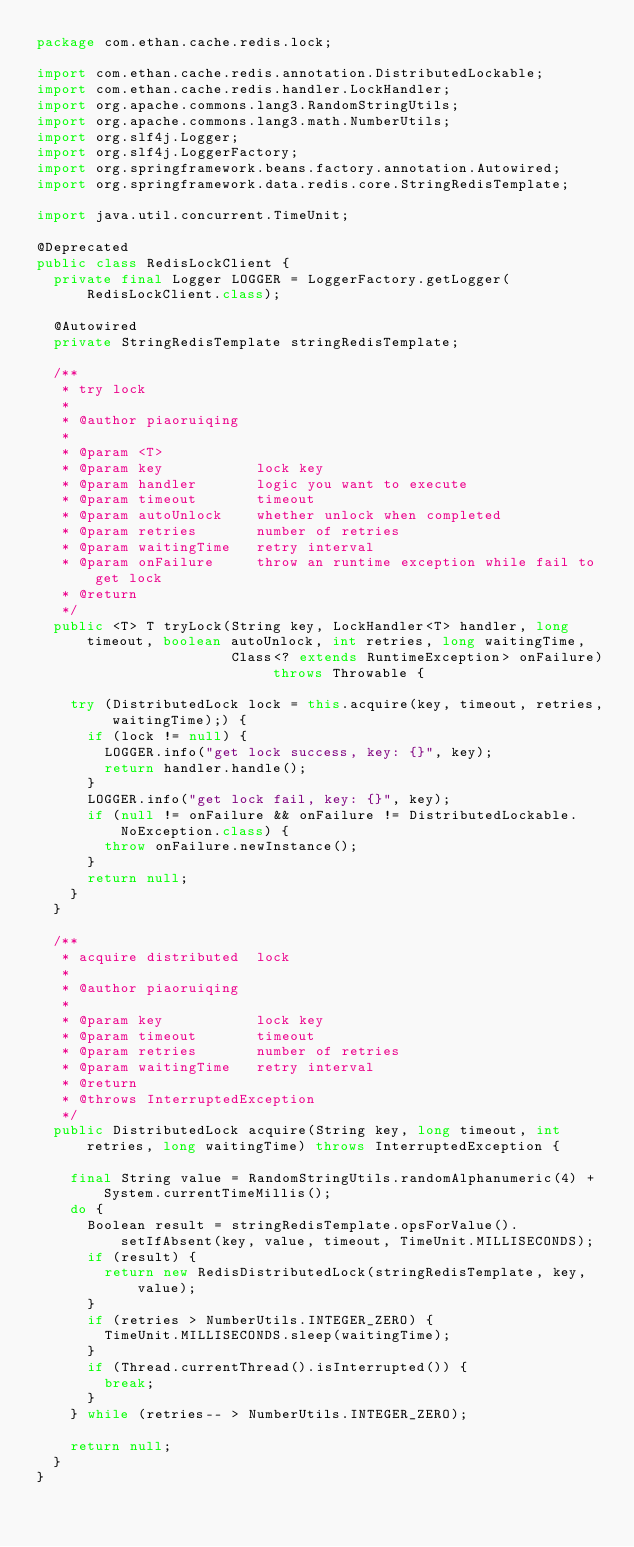Convert code to text. <code><loc_0><loc_0><loc_500><loc_500><_Java_>package com.ethan.cache.redis.lock;

import com.ethan.cache.redis.annotation.DistributedLockable;
import com.ethan.cache.redis.handler.LockHandler;
import org.apache.commons.lang3.RandomStringUtils;
import org.apache.commons.lang3.math.NumberUtils;
import org.slf4j.Logger;
import org.slf4j.LoggerFactory;
import org.springframework.beans.factory.annotation.Autowired;
import org.springframework.data.redis.core.StringRedisTemplate;

import java.util.concurrent.TimeUnit;

@Deprecated
public class RedisLockClient {
  private final Logger LOGGER = LoggerFactory.getLogger(RedisLockClient.class);

  @Autowired
  private StringRedisTemplate stringRedisTemplate;

  /**
   * try lock
   *
   * @author piaoruiqing
   *
   * @param <T>
   * @param key           lock key
   * @param handler       logic you want to execute
   * @param timeout       timeout
   * @param autoUnlock    whether unlock when completed
   * @param retries       number of retries
   * @param waitingTime   retry interval
   * @param onFailure     throw an runtime exception while fail to get lock
   * @return
   */
  public <T> T tryLock(String key, LockHandler<T> handler, long timeout, boolean autoUnlock, int retries, long waitingTime,
                       Class<? extends RuntimeException> onFailure) throws Throwable {

    try (DistributedLock lock = this.acquire(key, timeout, retries, waitingTime);) {
      if (lock != null) {
        LOGGER.info("get lock success, key: {}", key);
        return handler.handle();
      }
      LOGGER.info("get lock fail, key: {}", key);
      if (null != onFailure && onFailure != DistributedLockable.NoException.class) {
        throw onFailure.newInstance();
      }
      return null;
    }
  }

  /**
   * acquire distributed  lock
   *
   * @author piaoruiqing
   *
   * @param key           lock key
   * @param timeout       timeout
   * @param retries       number of retries
   * @param waitingTime   retry interval
   * @return
   * @throws InterruptedException
   */
  public DistributedLock acquire(String key, long timeout, int retries, long waitingTime) throws InterruptedException {

    final String value = RandomStringUtils.randomAlphanumeric(4) + System.currentTimeMillis();
    do {
      Boolean result = stringRedisTemplate.opsForValue().setIfAbsent(key, value, timeout, TimeUnit.MILLISECONDS);
      if (result) {
        return new RedisDistributedLock(stringRedisTemplate, key, value);
      }
      if (retries > NumberUtils.INTEGER_ZERO) {
        TimeUnit.MILLISECONDS.sleep(waitingTime);
      }
      if (Thread.currentThread().isInterrupted()) {
        break;
      }
    } while (retries-- > NumberUtils.INTEGER_ZERO);

    return null;
  }
}
</code> 